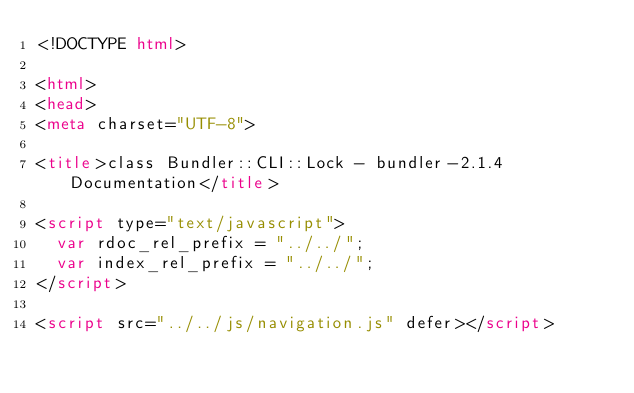<code> <loc_0><loc_0><loc_500><loc_500><_HTML_><!DOCTYPE html>

<html>
<head>
<meta charset="UTF-8">

<title>class Bundler::CLI::Lock - bundler-2.1.4 Documentation</title>

<script type="text/javascript">
  var rdoc_rel_prefix = "../../";
  var index_rel_prefix = "../../";
</script>

<script src="../../js/navigation.js" defer></script></code> 